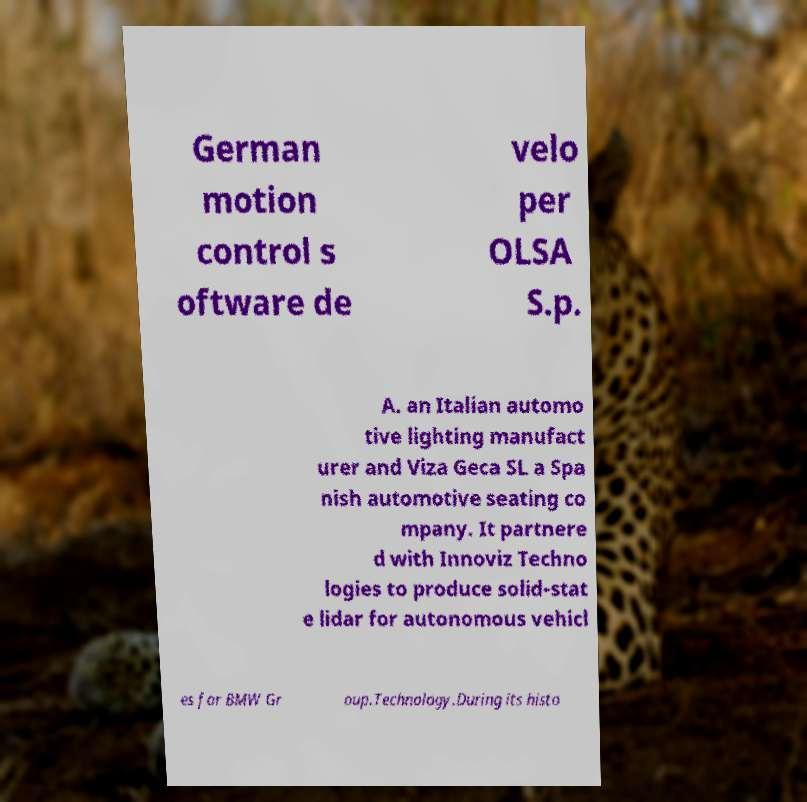Please read and relay the text visible in this image. What does it say? German motion control s oftware de velo per OLSA S.p. A. an Italian automo tive lighting manufact urer and Viza Geca SL a Spa nish automotive seating co mpany. It partnere d with Innoviz Techno logies to produce solid-stat e lidar for autonomous vehicl es for BMW Gr oup.Technology.During its histo 